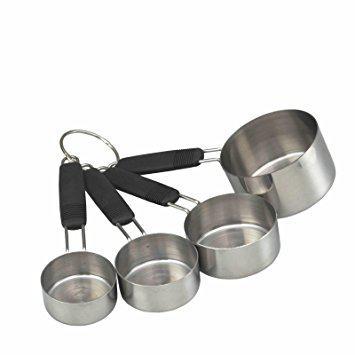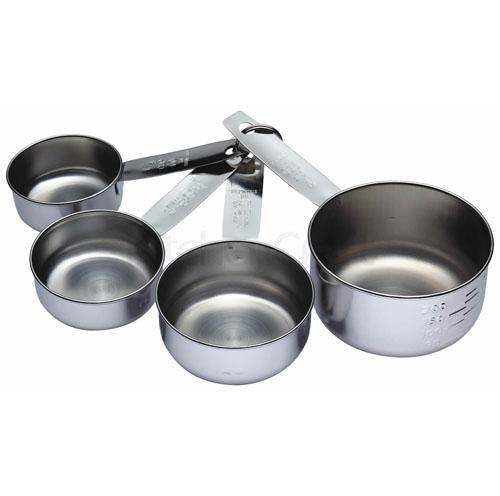The first image is the image on the left, the second image is the image on the right. Examine the images to the left and right. Is the description "There are five measuring cups in the right image" accurate? Answer yes or no. No. 